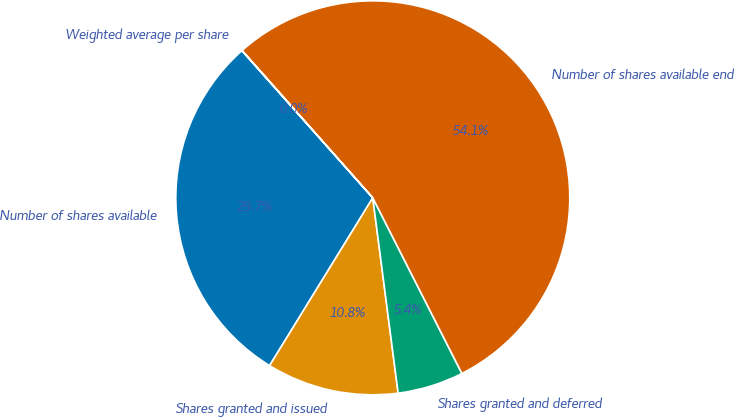Convert chart to OTSL. <chart><loc_0><loc_0><loc_500><loc_500><pie_chart><fcel>Number of shares available<fcel>Shares granted and issued<fcel>Shares granted and deferred<fcel>Number of shares available end<fcel>Weighted average per share<nl><fcel>29.66%<fcel>10.83%<fcel>5.42%<fcel>54.08%<fcel>0.02%<nl></chart> 